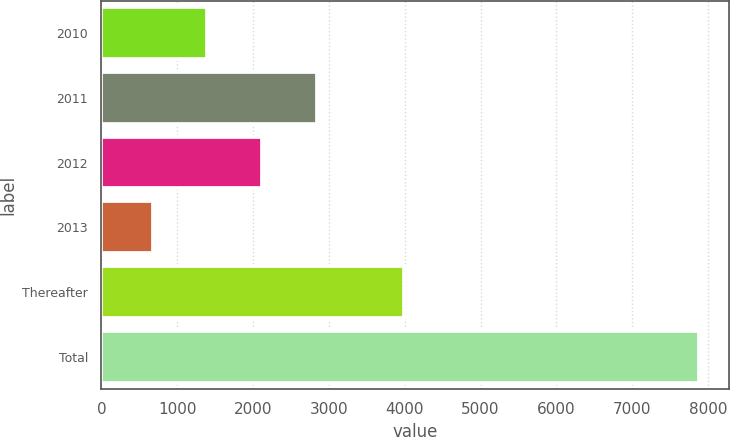Convert chart. <chart><loc_0><loc_0><loc_500><loc_500><bar_chart><fcel>2010<fcel>2011<fcel>2012<fcel>2013<fcel>Thereafter<fcel>Total<nl><fcel>1396.6<fcel>2837.8<fcel>2117.2<fcel>676<fcel>3988<fcel>7882<nl></chart> 